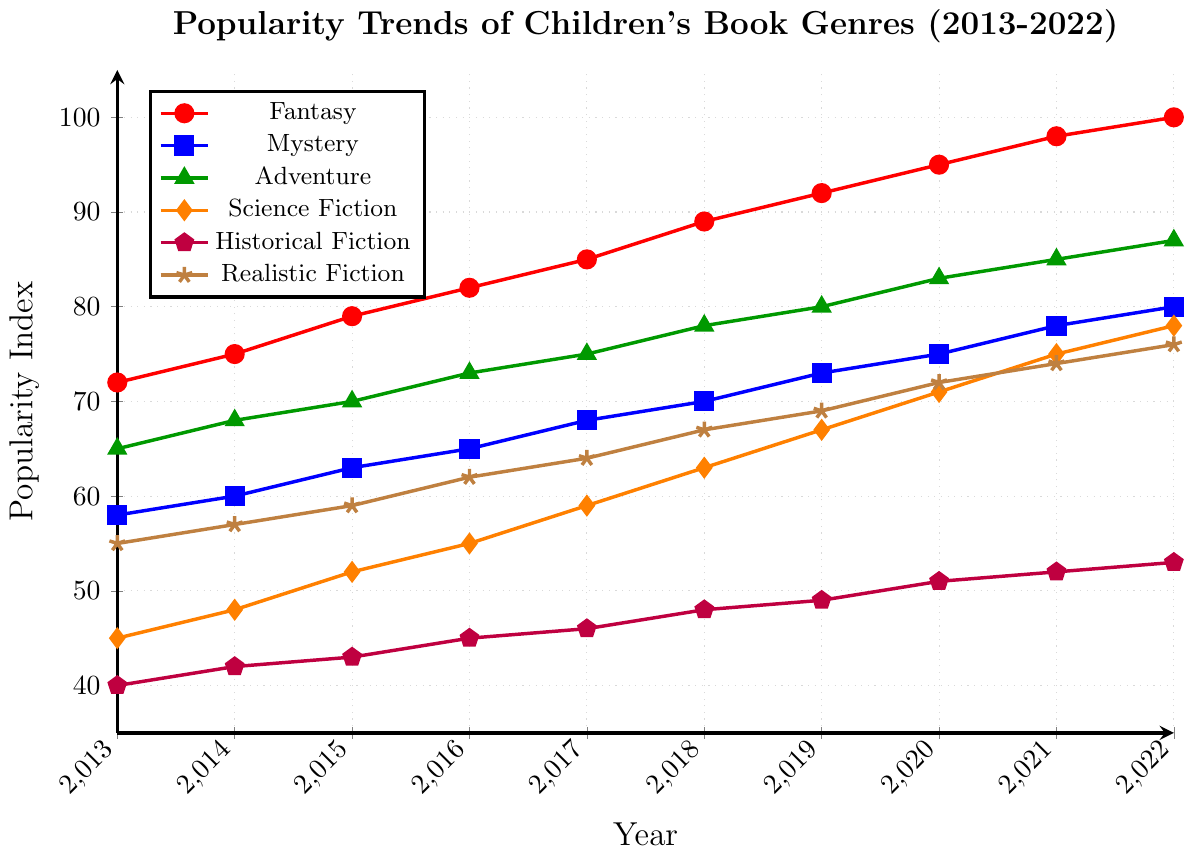Which genre had the highest popularity in 2013? Look at the y-axis values for each genre in 2013 and identify the highest value. Fantasy has the highest value of 72.
Answer: Fantasy Which genre showed the highest growth in popularity from 2013 to 2022? Calculate the difference in popularity values for each genre from 2013 to 2022 and identify the one with the highest increase. For Fantasy, the increase is 100 - 72 = 28, for Mystery it's 80 - 58 = 22, etc. Fantasy has the highest increase with 28 points.
Answer: Fantasy In what year did Realistic Fiction reach a popularity index of 72? Follow the trend line for Realistic Fiction and find the year where the index reaches 72. Realistic Fiction hits 72 in 2020.
Answer: 2020 How does the popularity growth of Science Fiction compare to Historical Fiction from 2013 to 2022? Calculate the growth for both genres. For Science Fiction, it's 78 - 45 = 33. For Historical Fiction, it's 53 - 40 = 13. Compare these values. Science Fiction grew more with an increase of 33 compared to 13 for Historical Fiction.
Answer: Science Fiction grew more Which genre had more popularity in 2019, Science Fiction or Realistic Fiction? Compare the y-axis values for Science Fiction and Realistic Fiction in 2019. Science Fiction had a value of 67, while Realistic Fiction had 69. Realistic Fiction is more popular.
Answer: Realistic Fiction Which genre shows a consistent positive trend without any dips from 2013 to 2022? Analyze the trend lines for each genre to identify which one(s) have a consistent upward slope without any dips. All genres show consistent positive trends without dips in the given period based on provided data.
Answer: All genres What was the average popularity of Fantasy and Mystery genres in 2017? Find the popularity values for both genres in 2017 and calculate the average. For Fantasy: 85, for Mystery: 68. (85 + 68) / 2 = 76.5
Answer: 76.5 Which genre was less popular in 2016, Adventure or Historical Fiction? Compare the y-axis values for Adventure and Historical Fiction in 2016. Adventure had 73, while Historical Fiction had 45. Historical Fiction is less popular.
Answer: Historical Fiction What’s the sum of the popularity indices for all genres in 2015? Add the popularity values for all genres in 2015. 79 (Fantasy) + 63 (Mystery) + 70 (Adventure) + 52 (Science Fiction) + 43 (Historical Fiction) + 59 (Realistic Fiction) = 366
Answer: 366 